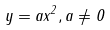<formula> <loc_0><loc_0><loc_500><loc_500>y = a x ^ { 2 } , a \ne 0</formula> 